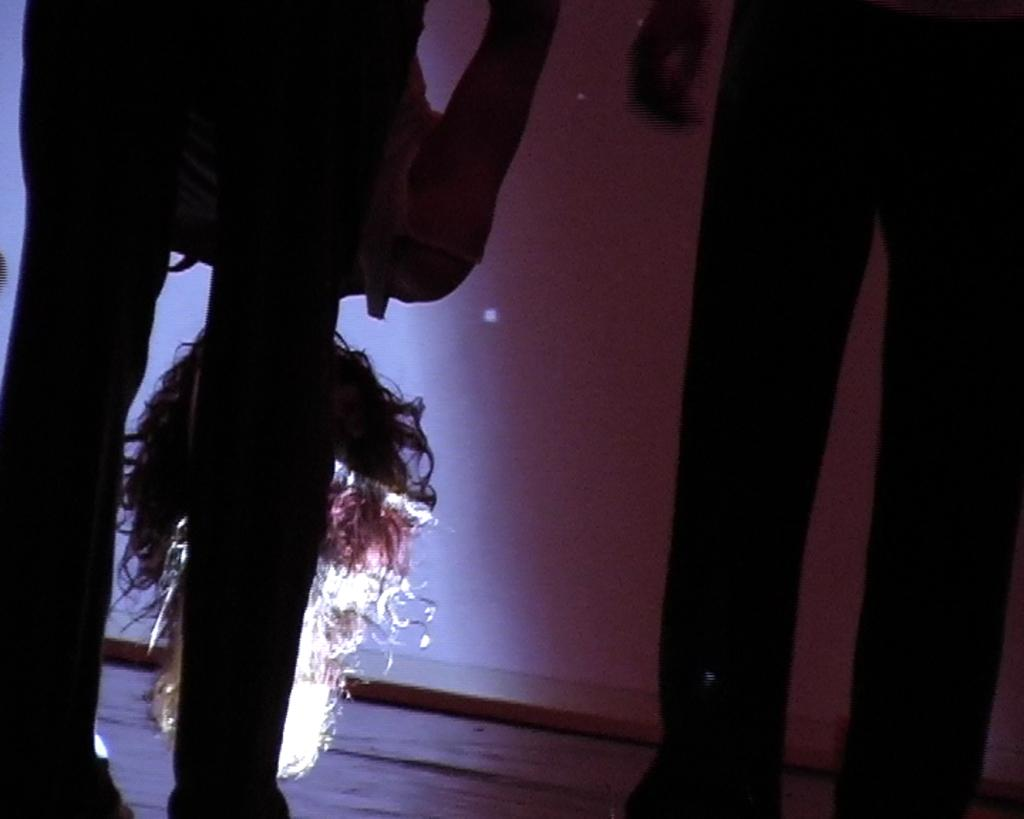What is the position of the person in the image? There is a person standing on the right side of the image. What is the girl doing in the image? There is a girl bending on the left side of the image. What detail is highlighted about the girl's appearance? The girl's hair has a light focus on it. What does the caption say about the girl's laugh in the image? There is no caption present in the image, so it is not possible to determine what it might say about the girl's laugh. 